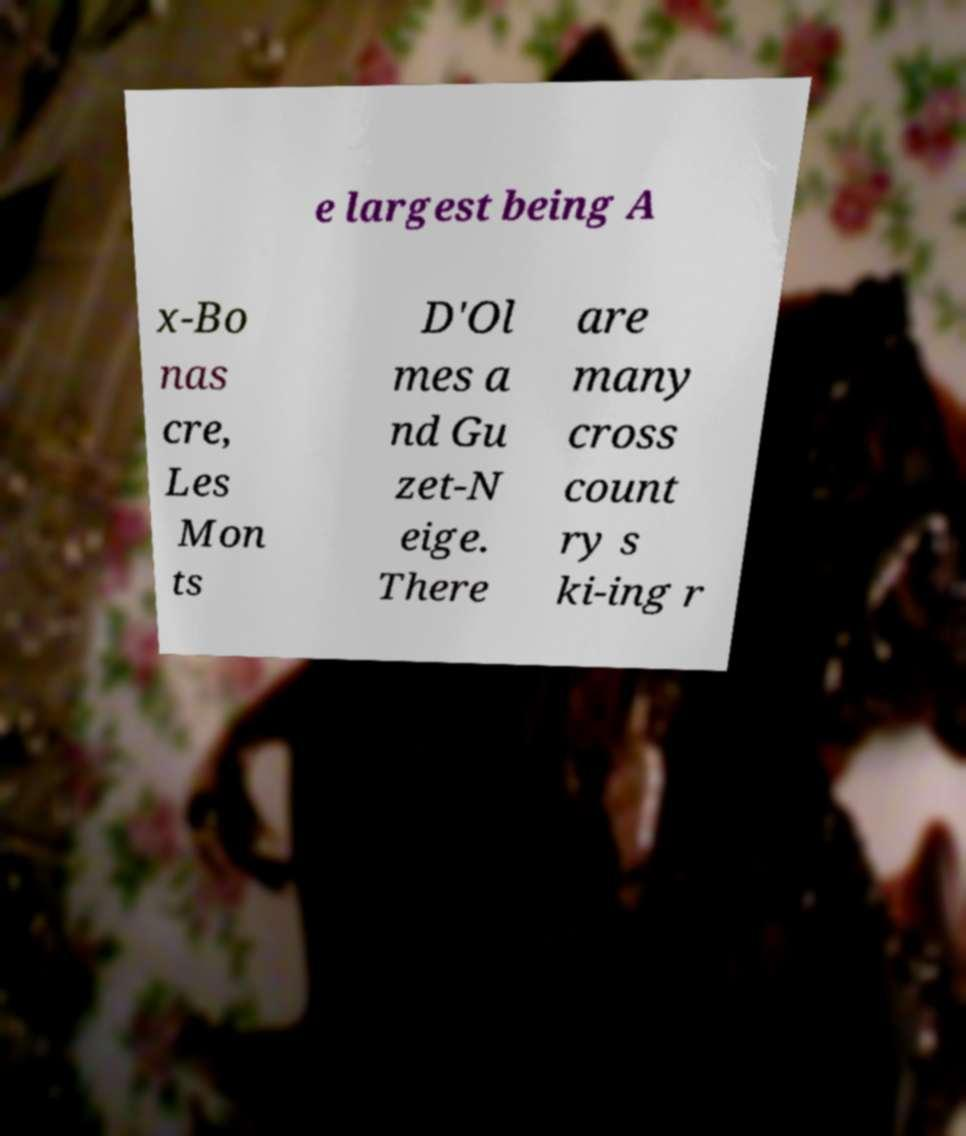For documentation purposes, I need the text within this image transcribed. Could you provide that? e largest being A x-Bo nas cre, Les Mon ts D'Ol mes a nd Gu zet-N eige. There are many cross count ry s ki-ing r 